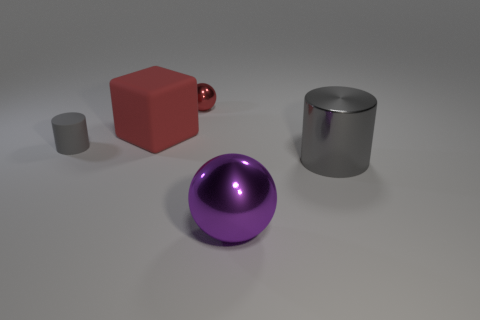Does the large gray shiny thing have the same shape as the large purple thing?
Provide a short and direct response. No. Are there any small gray objects made of the same material as the large block?
Provide a short and direct response. Yes. What is the color of the metal object that is to the left of the big gray object and in front of the red shiny sphere?
Provide a succinct answer. Purple. There is a cylinder that is on the left side of the large red object; what is its material?
Keep it short and to the point. Rubber. Is there a yellow shiny object that has the same shape as the small gray thing?
Your answer should be very brief. No. How many other things are the same shape as the big purple thing?
Make the answer very short. 1. There is a small gray thing; is its shape the same as the tiny object to the right of the matte cylinder?
Your answer should be compact. No. Is there anything else that is the same material as the small cylinder?
Make the answer very short. Yes. What is the material of the other gray object that is the same shape as the gray metallic object?
Ensure brevity in your answer.  Rubber. How many tiny objects are either gray metallic cylinders or metal things?
Provide a succinct answer. 1. 